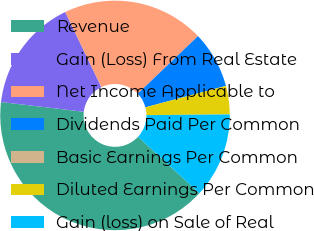Convert chart to OTSL. <chart><loc_0><loc_0><loc_500><loc_500><pie_chart><fcel>Revenue<fcel>Gain (Loss) From Real Estate<fcel>Net Income Applicable to<fcel>Dividends Paid Per Common<fcel>Basic Earnings Per Common<fcel>Diluted Earnings Per Common<fcel>Gain (loss) on Sale of Real<nl><fcel>40.0%<fcel>16.0%<fcel>20.0%<fcel>8.0%<fcel>0.0%<fcel>4.0%<fcel>12.0%<nl></chart> 